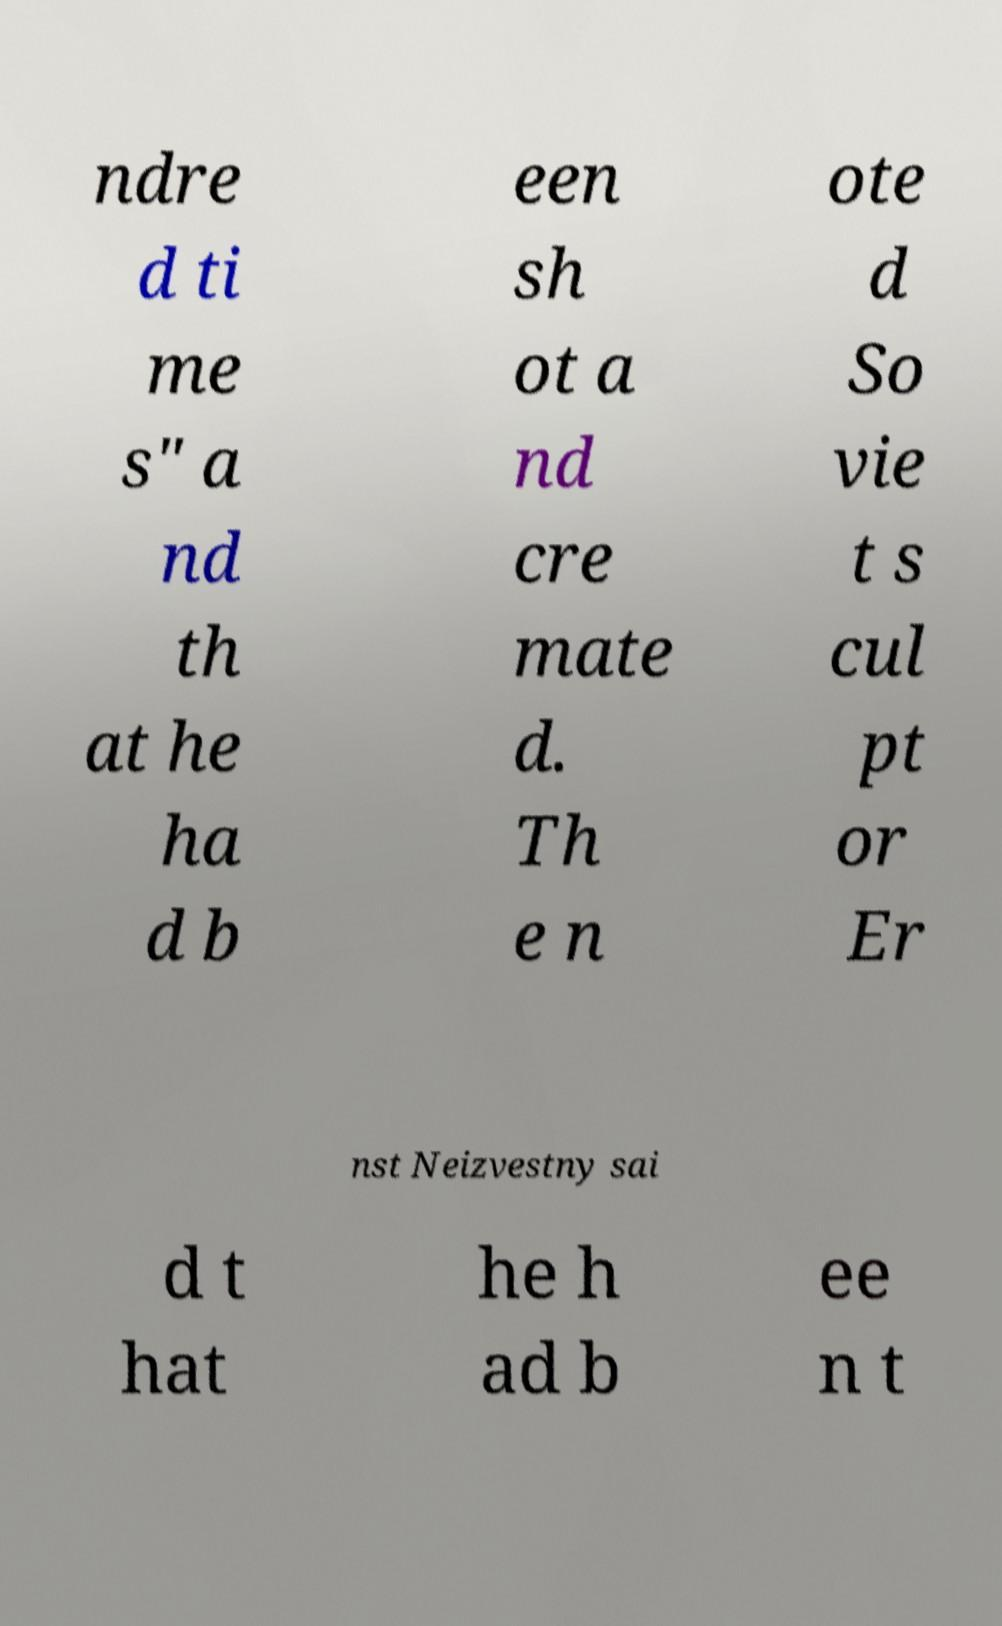Could you extract and type out the text from this image? ndre d ti me s" a nd th at he ha d b een sh ot a nd cre mate d. Th e n ote d So vie t s cul pt or Er nst Neizvestny sai d t hat he h ad b ee n t 